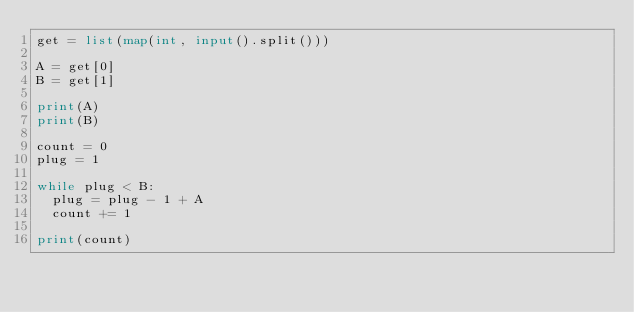<code> <loc_0><loc_0><loc_500><loc_500><_Python_>get = list(map(int, input().split()))

A = get[0]
B = get[1]

print(A)
print(B)

count = 0
plug = 1

while plug < B:
  plug = plug - 1 + A
  count += 1
  
print(count)</code> 